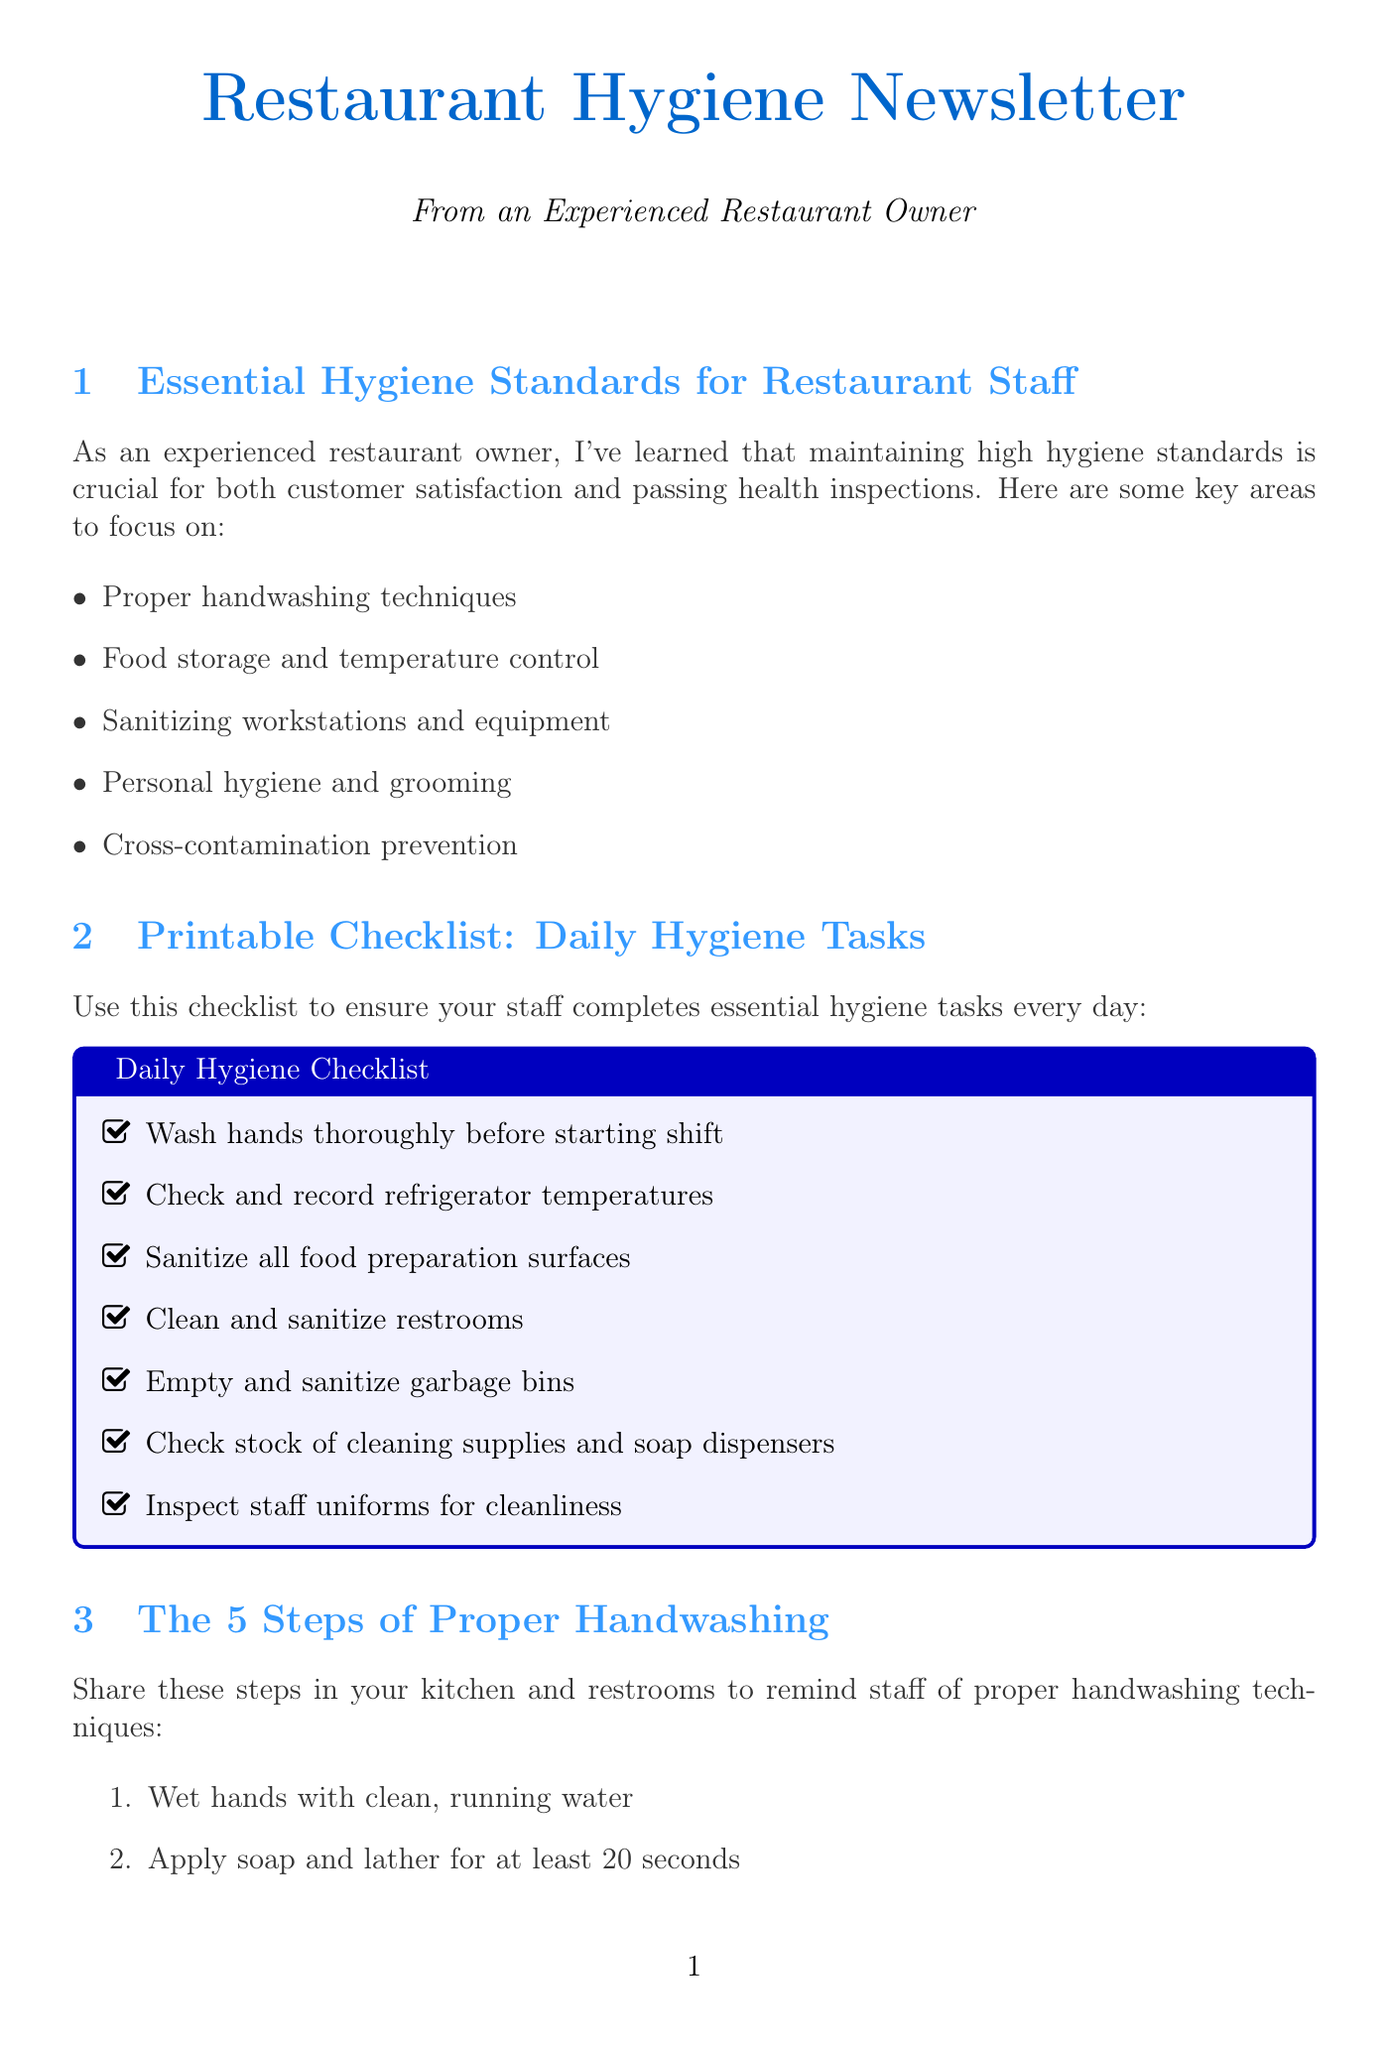What are the key areas to focus on for hygiene standards? The document lists key areas such as proper handwashing techniques, food storage and temperature control, sanitizing workstations and equipment, personal hygiene and grooming, and cross-contamination prevention.
Answer: Proper handwashing techniques, food storage and temperature control, sanitizing workstations and equipment, personal hygiene and grooming, cross-contamination prevention What is included in the daily hygiene checklist? The checklist includes tasks like washing hands, checking refrigerator temperatures, sanitizing surfaces, cleaning restrooms, and inspecting staff uniforms.
Answer: Wash hands thoroughly before starting shift, check and record refrigerator temperatures, sanitize all food preparation surfaces, clean and sanitize restrooms, empty and sanitize garbage bins, check stock of cleaning supplies and soap dispensers, inspect staff uniforms for cleanliness How many steps are there in proper handwashing? The document explicitly states the steps for proper handwashing, which are numbered, indicating the total count.
Answer: 5 What innovative technology is mentioned for maintaining hygiene? The document highlights new hygiene technology, providing a list of solutions to enhance hygiene practices in the restaurant.
Answer: TouchFree hand sanitizer dispensers by Purell, Bluezone by Middleby air purification system, PathSpot hand hygiene verification system, Ecolab's Smartpower dishwasher monitoring system What date and time should staff attend the food safety certification course? The document indicates that the specific date and time are placeholders, meant to be filled in later.
Answer: [DATE] at [TIME] What is the most common violation related to personal hygiene practices? The violations section highlights that poor personal hygiene practices among staff are frequently encountered during health inspections.
Answer: Poor personal hygiene practices among staff 